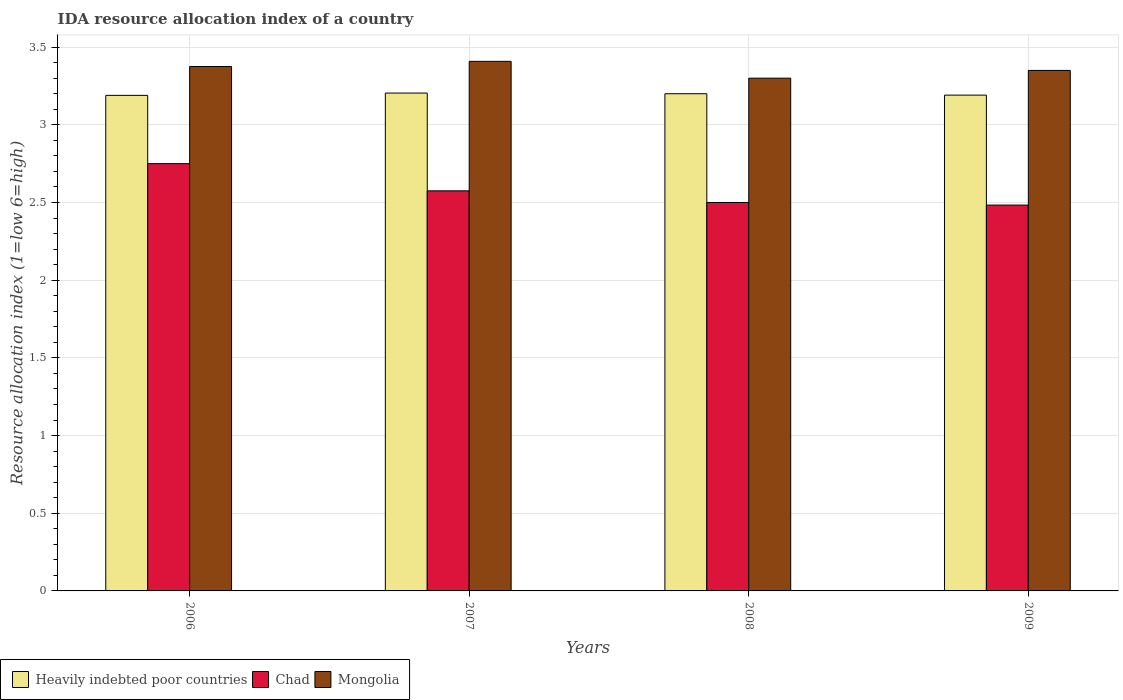How many different coloured bars are there?
Your answer should be compact. 3. Are the number of bars per tick equal to the number of legend labels?
Your answer should be compact. Yes. Are the number of bars on each tick of the X-axis equal?
Make the answer very short. Yes. How many bars are there on the 3rd tick from the left?
Ensure brevity in your answer.  3. What is the label of the 2nd group of bars from the left?
Give a very brief answer. 2007. What is the IDA resource allocation index in Mongolia in 2006?
Offer a terse response. 3.38. Across all years, what is the maximum IDA resource allocation index in Chad?
Provide a short and direct response. 2.75. What is the total IDA resource allocation index in Mongolia in the graph?
Provide a succinct answer. 13.43. What is the difference between the IDA resource allocation index in Heavily indebted poor countries in 2006 and that in 2007?
Your answer should be compact. -0.01. What is the difference between the IDA resource allocation index in Mongolia in 2007 and the IDA resource allocation index in Heavily indebted poor countries in 2006?
Make the answer very short. 0.22. What is the average IDA resource allocation index in Heavily indebted poor countries per year?
Provide a short and direct response. 3.2. In the year 2009, what is the difference between the IDA resource allocation index in Mongolia and IDA resource allocation index in Heavily indebted poor countries?
Provide a short and direct response. 0.16. What is the ratio of the IDA resource allocation index in Heavily indebted poor countries in 2006 to that in 2008?
Give a very brief answer. 1. Is the difference between the IDA resource allocation index in Mongolia in 2007 and 2008 greater than the difference between the IDA resource allocation index in Heavily indebted poor countries in 2007 and 2008?
Provide a succinct answer. Yes. What is the difference between the highest and the second highest IDA resource allocation index in Chad?
Provide a short and direct response. 0.17. What is the difference between the highest and the lowest IDA resource allocation index in Mongolia?
Your answer should be very brief. 0.11. In how many years, is the IDA resource allocation index in Heavily indebted poor countries greater than the average IDA resource allocation index in Heavily indebted poor countries taken over all years?
Offer a terse response. 2. Is the sum of the IDA resource allocation index in Mongolia in 2006 and 2009 greater than the maximum IDA resource allocation index in Chad across all years?
Offer a terse response. Yes. What does the 1st bar from the left in 2009 represents?
Your answer should be compact. Heavily indebted poor countries. What does the 1st bar from the right in 2007 represents?
Ensure brevity in your answer.  Mongolia. How many bars are there?
Make the answer very short. 12. Are all the bars in the graph horizontal?
Give a very brief answer. No. What is the difference between two consecutive major ticks on the Y-axis?
Offer a terse response. 0.5. Are the values on the major ticks of Y-axis written in scientific E-notation?
Keep it short and to the point. No. Does the graph contain any zero values?
Give a very brief answer. No. Does the graph contain grids?
Provide a succinct answer. Yes. How many legend labels are there?
Your answer should be compact. 3. What is the title of the graph?
Your answer should be compact. IDA resource allocation index of a country. Does "Barbados" appear as one of the legend labels in the graph?
Keep it short and to the point. No. What is the label or title of the Y-axis?
Give a very brief answer. Resource allocation index (1=low 6=high). What is the Resource allocation index (1=low 6=high) in Heavily indebted poor countries in 2006?
Keep it short and to the point. 3.19. What is the Resource allocation index (1=low 6=high) of Chad in 2006?
Offer a very short reply. 2.75. What is the Resource allocation index (1=low 6=high) of Mongolia in 2006?
Your answer should be very brief. 3.38. What is the Resource allocation index (1=low 6=high) in Heavily indebted poor countries in 2007?
Give a very brief answer. 3.2. What is the Resource allocation index (1=low 6=high) of Chad in 2007?
Keep it short and to the point. 2.58. What is the Resource allocation index (1=low 6=high) in Mongolia in 2007?
Offer a terse response. 3.41. What is the Resource allocation index (1=low 6=high) of Mongolia in 2008?
Offer a terse response. 3.3. What is the Resource allocation index (1=low 6=high) of Heavily indebted poor countries in 2009?
Your answer should be compact. 3.19. What is the Resource allocation index (1=low 6=high) in Chad in 2009?
Your answer should be compact. 2.48. What is the Resource allocation index (1=low 6=high) in Mongolia in 2009?
Offer a terse response. 3.35. Across all years, what is the maximum Resource allocation index (1=low 6=high) in Heavily indebted poor countries?
Make the answer very short. 3.2. Across all years, what is the maximum Resource allocation index (1=low 6=high) of Chad?
Give a very brief answer. 2.75. Across all years, what is the maximum Resource allocation index (1=low 6=high) in Mongolia?
Your response must be concise. 3.41. Across all years, what is the minimum Resource allocation index (1=low 6=high) in Heavily indebted poor countries?
Make the answer very short. 3.19. Across all years, what is the minimum Resource allocation index (1=low 6=high) in Chad?
Offer a terse response. 2.48. Across all years, what is the minimum Resource allocation index (1=low 6=high) in Mongolia?
Provide a short and direct response. 3.3. What is the total Resource allocation index (1=low 6=high) in Heavily indebted poor countries in the graph?
Your answer should be very brief. 12.78. What is the total Resource allocation index (1=low 6=high) in Chad in the graph?
Provide a succinct answer. 10.31. What is the total Resource allocation index (1=low 6=high) of Mongolia in the graph?
Offer a terse response. 13.43. What is the difference between the Resource allocation index (1=low 6=high) of Heavily indebted poor countries in 2006 and that in 2007?
Keep it short and to the point. -0.01. What is the difference between the Resource allocation index (1=low 6=high) in Chad in 2006 and that in 2007?
Provide a succinct answer. 0.17. What is the difference between the Resource allocation index (1=low 6=high) in Mongolia in 2006 and that in 2007?
Provide a short and direct response. -0.03. What is the difference between the Resource allocation index (1=low 6=high) of Heavily indebted poor countries in 2006 and that in 2008?
Offer a terse response. -0.01. What is the difference between the Resource allocation index (1=low 6=high) in Mongolia in 2006 and that in 2008?
Provide a short and direct response. 0.07. What is the difference between the Resource allocation index (1=low 6=high) of Heavily indebted poor countries in 2006 and that in 2009?
Make the answer very short. -0. What is the difference between the Resource allocation index (1=low 6=high) in Chad in 2006 and that in 2009?
Offer a terse response. 0.27. What is the difference between the Resource allocation index (1=low 6=high) in Mongolia in 2006 and that in 2009?
Offer a very short reply. 0.03. What is the difference between the Resource allocation index (1=low 6=high) in Heavily indebted poor countries in 2007 and that in 2008?
Your response must be concise. 0. What is the difference between the Resource allocation index (1=low 6=high) in Chad in 2007 and that in 2008?
Your response must be concise. 0.07. What is the difference between the Resource allocation index (1=low 6=high) in Mongolia in 2007 and that in 2008?
Your answer should be compact. 0.11. What is the difference between the Resource allocation index (1=low 6=high) in Heavily indebted poor countries in 2007 and that in 2009?
Offer a terse response. 0.01. What is the difference between the Resource allocation index (1=low 6=high) of Chad in 2007 and that in 2009?
Provide a succinct answer. 0.09. What is the difference between the Resource allocation index (1=low 6=high) of Mongolia in 2007 and that in 2009?
Your answer should be compact. 0.06. What is the difference between the Resource allocation index (1=low 6=high) of Heavily indebted poor countries in 2008 and that in 2009?
Offer a very short reply. 0.01. What is the difference between the Resource allocation index (1=low 6=high) of Chad in 2008 and that in 2009?
Your answer should be compact. 0.02. What is the difference between the Resource allocation index (1=low 6=high) in Heavily indebted poor countries in 2006 and the Resource allocation index (1=low 6=high) in Chad in 2007?
Provide a short and direct response. 0.61. What is the difference between the Resource allocation index (1=low 6=high) of Heavily indebted poor countries in 2006 and the Resource allocation index (1=low 6=high) of Mongolia in 2007?
Provide a short and direct response. -0.22. What is the difference between the Resource allocation index (1=low 6=high) of Chad in 2006 and the Resource allocation index (1=low 6=high) of Mongolia in 2007?
Your response must be concise. -0.66. What is the difference between the Resource allocation index (1=low 6=high) of Heavily indebted poor countries in 2006 and the Resource allocation index (1=low 6=high) of Chad in 2008?
Offer a terse response. 0.69. What is the difference between the Resource allocation index (1=low 6=high) in Heavily indebted poor countries in 2006 and the Resource allocation index (1=low 6=high) in Mongolia in 2008?
Provide a succinct answer. -0.11. What is the difference between the Resource allocation index (1=low 6=high) of Chad in 2006 and the Resource allocation index (1=low 6=high) of Mongolia in 2008?
Make the answer very short. -0.55. What is the difference between the Resource allocation index (1=low 6=high) in Heavily indebted poor countries in 2006 and the Resource allocation index (1=low 6=high) in Chad in 2009?
Provide a succinct answer. 0.71. What is the difference between the Resource allocation index (1=low 6=high) in Heavily indebted poor countries in 2006 and the Resource allocation index (1=low 6=high) in Mongolia in 2009?
Your response must be concise. -0.16. What is the difference between the Resource allocation index (1=low 6=high) of Chad in 2006 and the Resource allocation index (1=low 6=high) of Mongolia in 2009?
Give a very brief answer. -0.6. What is the difference between the Resource allocation index (1=low 6=high) of Heavily indebted poor countries in 2007 and the Resource allocation index (1=low 6=high) of Chad in 2008?
Your answer should be compact. 0.7. What is the difference between the Resource allocation index (1=low 6=high) of Heavily indebted poor countries in 2007 and the Resource allocation index (1=low 6=high) of Mongolia in 2008?
Provide a succinct answer. -0.1. What is the difference between the Resource allocation index (1=low 6=high) of Chad in 2007 and the Resource allocation index (1=low 6=high) of Mongolia in 2008?
Keep it short and to the point. -0.72. What is the difference between the Resource allocation index (1=low 6=high) of Heavily indebted poor countries in 2007 and the Resource allocation index (1=low 6=high) of Chad in 2009?
Give a very brief answer. 0.72. What is the difference between the Resource allocation index (1=low 6=high) in Heavily indebted poor countries in 2007 and the Resource allocation index (1=low 6=high) in Mongolia in 2009?
Provide a succinct answer. -0.15. What is the difference between the Resource allocation index (1=low 6=high) in Chad in 2007 and the Resource allocation index (1=low 6=high) in Mongolia in 2009?
Offer a very short reply. -0.78. What is the difference between the Resource allocation index (1=low 6=high) in Heavily indebted poor countries in 2008 and the Resource allocation index (1=low 6=high) in Chad in 2009?
Give a very brief answer. 0.72. What is the difference between the Resource allocation index (1=low 6=high) of Chad in 2008 and the Resource allocation index (1=low 6=high) of Mongolia in 2009?
Ensure brevity in your answer.  -0.85. What is the average Resource allocation index (1=low 6=high) of Heavily indebted poor countries per year?
Keep it short and to the point. 3.2. What is the average Resource allocation index (1=low 6=high) of Chad per year?
Make the answer very short. 2.58. What is the average Resource allocation index (1=low 6=high) of Mongolia per year?
Your answer should be very brief. 3.36. In the year 2006, what is the difference between the Resource allocation index (1=low 6=high) in Heavily indebted poor countries and Resource allocation index (1=low 6=high) in Chad?
Give a very brief answer. 0.44. In the year 2006, what is the difference between the Resource allocation index (1=low 6=high) in Heavily indebted poor countries and Resource allocation index (1=low 6=high) in Mongolia?
Your response must be concise. -0.19. In the year 2006, what is the difference between the Resource allocation index (1=low 6=high) in Chad and Resource allocation index (1=low 6=high) in Mongolia?
Your response must be concise. -0.62. In the year 2007, what is the difference between the Resource allocation index (1=low 6=high) of Heavily indebted poor countries and Resource allocation index (1=low 6=high) of Chad?
Keep it short and to the point. 0.63. In the year 2007, what is the difference between the Resource allocation index (1=low 6=high) of Heavily indebted poor countries and Resource allocation index (1=low 6=high) of Mongolia?
Provide a succinct answer. -0.2. In the year 2008, what is the difference between the Resource allocation index (1=low 6=high) of Heavily indebted poor countries and Resource allocation index (1=low 6=high) of Chad?
Ensure brevity in your answer.  0.7. In the year 2008, what is the difference between the Resource allocation index (1=low 6=high) of Heavily indebted poor countries and Resource allocation index (1=low 6=high) of Mongolia?
Offer a terse response. -0.1. In the year 2009, what is the difference between the Resource allocation index (1=low 6=high) in Heavily indebted poor countries and Resource allocation index (1=low 6=high) in Chad?
Offer a very short reply. 0.71. In the year 2009, what is the difference between the Resource allocation index (1=low 6=high) of Heavily indebted poor countries and Resource allocation index (1=low 6=high) of Mongolia?
Give a very brief answer. -0.16. In the year 2009, what is the difference between the Resource allocation index (1=low 6=high) of Chad and Resource allocation index (1=low 6=high) of Mongolia?
Your answer should be compact. -0.87. What is the ratio of the Resource allocation index (1=low 6=high) of Chad in 2006 to that in 2007?
Keep it short and to the point. 1.07. What is the ratio of the Resource allocation index (1=low 6=high) of Mongolia in 2006 to that in 2007?
Offer a terse response. 0.99. What is the ratio of the Resource allocation index (1=low 6=high) of Heavily indebted poor countries in 2006 to that in 2008?
Make the answer very short. 1. What is the ratio of the Resource allocation index (1=low 6=high) in Mongolia in 2006 to that in 2008?
Your answer should be compact. 1.02. What is the ratio of the Resource allocation index (1=low 6=high) of Chad in 2006 to that in 2009?
Offer a terse response. 1.11. What is the ratio of the Resource allocation index (1=low 6=high) in Mongolia in 2006 to that in 2009?
Ensure brevity in your answer.  1.01. What is the ratio of the Resource allocation index (1=low 6=high) of Chad in 2007 to that in 2008?
Offer a very short reply. 1.03. What is the ratio of the Resource allocation index (1=low 6=high) in Mongolia in 2007 to that in 2008?
Give a very brief answer. 1.03. What is the ratio of the Resource allocation index (1=low 6=high) of Heavily indebted poor countries in 2007 to that in 2009?
Make the answer very short. 1. What is the ratio of the Resource allocation index (1=low 6=high) in Chad in 2007 to that in 2009?
Your answer should be very brief. 1.04. What is the ratio of the Resource allocation index (1=low 6=high) in Mongolia in 2007 to that in 2009?
Make the answer very short. 1.02. What is the ratio of the Resource allocation index (1=low 6=high) in Heavily indebted poor countries in 2008 to that in 2009?
Your answer should be very brief. 1. What is the ratio of the Resource allocation index (1=low 6=high) of Chad in 2008 to that in 2009?
Keep it short and to the point. 1.01. What is the ratio of the Resource allocation index (1=low 6=high) in Mongolia in 2008 to that in 2009?
Keep it short and to the point. 0.99. What is the difference between the highest and the second highest Resource allocation index (1=low 6=high) in Heavily indebted poor countries?
Provide a succinct answer. 0. What is the difference between the highest and the second highest Resource allocation index (1=low 6=high) in Chad?
Your answer should be compact. 0.17. What is the difference between the highest and the second highest Resource allocation index (1=low 6=high) of Mongolia?
Ensure brevity in your answer.  0.03. What is the difference between the highest and the lowest Resource allocation index (1=low 6=high) of Heavily indebted poor countries?
Your answer should be compact. 0.01. What is the difference between the highest and the lowest Resource allocation index (1=low 6=high) of Chad?
Keep it short and to the point. 0.27. What is the difference between the highest and the lowest Resource allocation index (1=low 6=high) of Mongolia?
Provide a succinct answer. 0.11. 